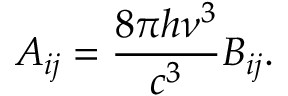Convert formula to latex. <formula><loc_0><loc_0><loc_500><loc_500>A _ { i j } = { \frac { 8 \pi h \nu ^ { 3 } } { c ^ { 3 } } } B _ { i j } .</formula> 